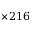Convert formula to latex. <formula><loc_0><loc_0><loc_500><loc_500>\times 2 1 6</formula> 